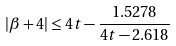<formula> <loc_0><loc_0><loc_500><loc_500>| \beta + 4 | \leq 4 t - \frac { 1 . 5 2 7 8 } { 4 t - 2 . 6 1 8 }</formula> 